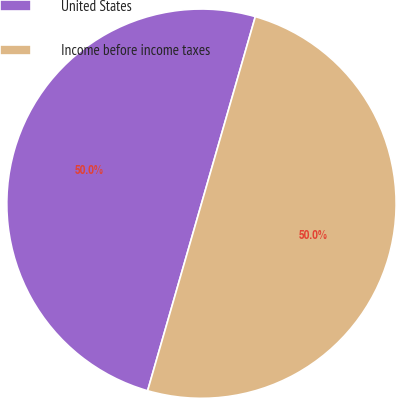Convert chart. <chart><loc_0><loc_0><loc_500><loc_500><pie_chart><fcel>United States<fcel>Income before income taxes<nl><fcel>50.0%<fcel>50.0%<nl></chart> 